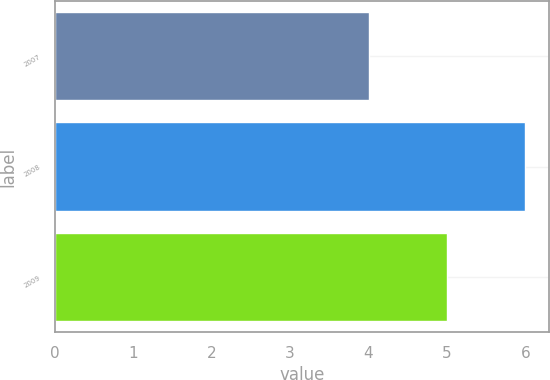<chart> <loc_0><loc_0><loc_500><loc_500><bar_chart><fcel>2007<fcel>2008<fcel>2009<nl><fcel>4<fcel>6<fcel>5<nl></chart> 